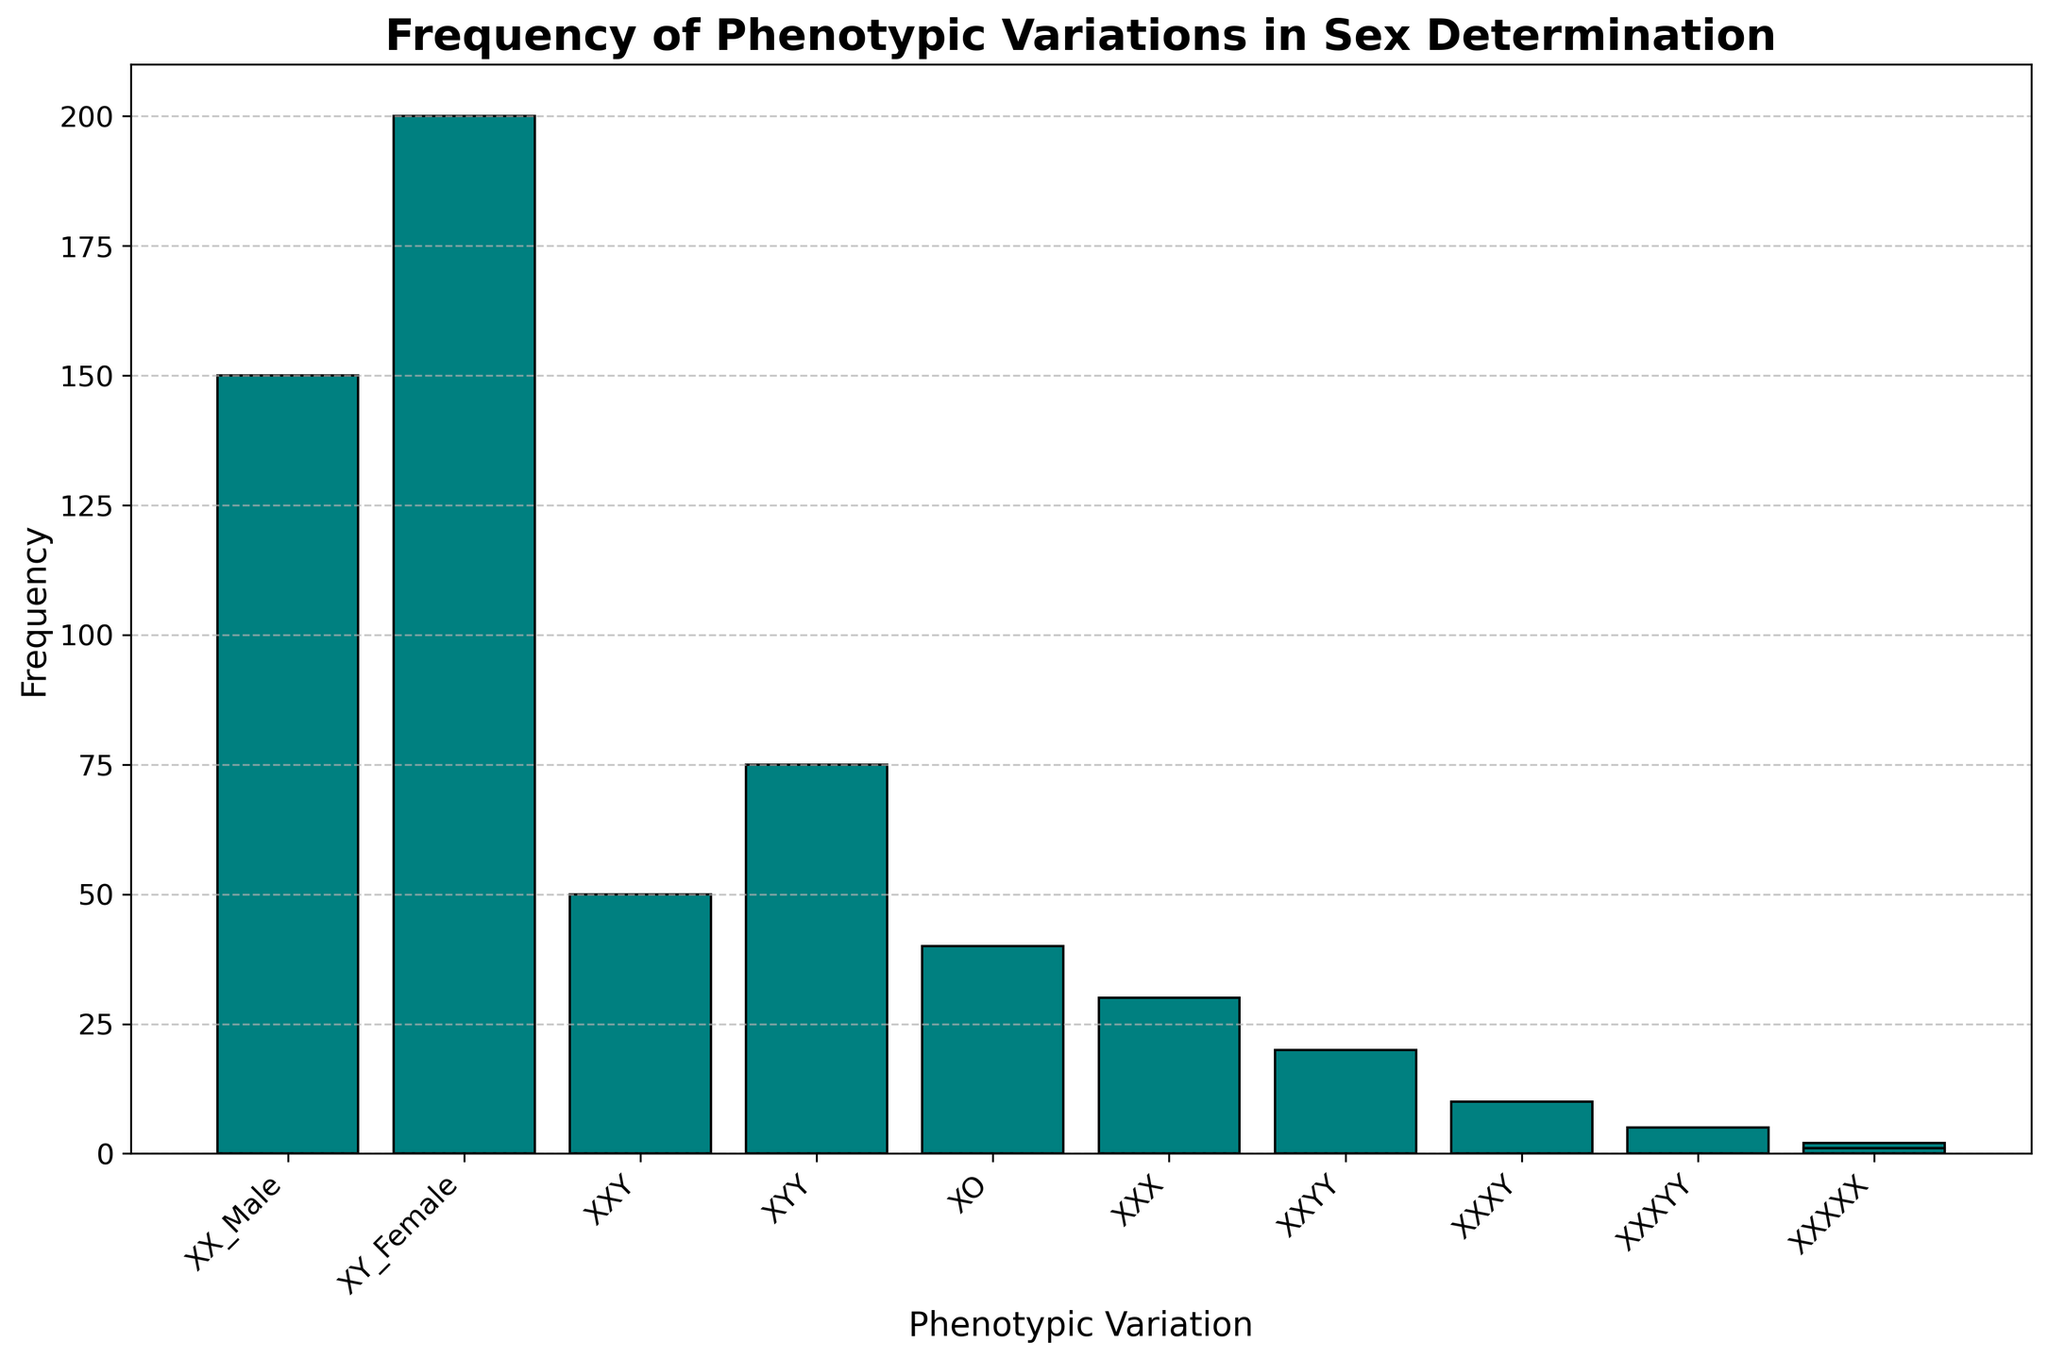What's the phenotypic variation with the highest frequency in the figure? By observing the bar heights, the phenotypic variation with the highest frequency appears to be "XY_Female". This bar is visibly taller than the others.
Answer: XY_Female How many total phenotypic variations are represented in the figure? Count the different bars representing distinct phenotypic variations. There are 10 variations in total: XX_Male, XY_Female, XXY, XYY, XO, XXX, XXYY, XXXY, XXXYY, and XXXXX.
Answer: 10 What is the difference in frequency between XX_Male and XY_Female? Subtract the frequency of XX_Male (150) from the frequency of XY_Female (200). 200 - 150 = 50.
Answer: 50 Which phenotypic variation has a frequency less than 20? Identify the bars with heights corresponding to frequencies below 20. These are XXYY, XXXY, XXXYY, and XXXXX.
Answer: XXYY, XXXY, XXXYY, and XXXXX What's the total frequency of phenotypic variations that have less than 100 occurrences? Sum the frequencies of variations with less than 100 occurrences: XXY (50), XYY (75), XO (40), XXX (30), XXYY (20), XXXY (10), XXXYY (5), and XXXXX (2 + 1). 50 + 75 + 40 + 30 + 20 + 10 + 5 + 2 + 1 = 233.
Answer: 233 What is the relative height of the bar representing XO compared to XX_Male? Calculate the ratio of frequencies between XO (40) and XX_Male (150). 40 ÷ 150 = 0.27. So the bar height of XO is 27% of the height of the XX_Male bar.
Answer: 27% Which phenotypic variations have less frequency than XYY but more frequency than XXX? Identify variations that fit this range: less than XYY (75) and more than XXX (30). These are XXY (50) and XO (40).
Answer: XXY and XO If we combine the frequencies of XXXY and XXXYY, would their total frequency be higher than that of XXYY? Add the frequencies of XXXY (10) and XXXYY (5) and compare it to the frequency of XXYY (20). 10 + 5 = 15, which is less than 20.
Answer: No Which phenotypic variation frequency is closest to the median value of all frequencies? Order the frequencies and find the median: 1, 2, 5, 10, 20, 30, 40, 50, 75, 150, 200. The median is the 6th value, which is 30 (XXX).
Answer: XXX 